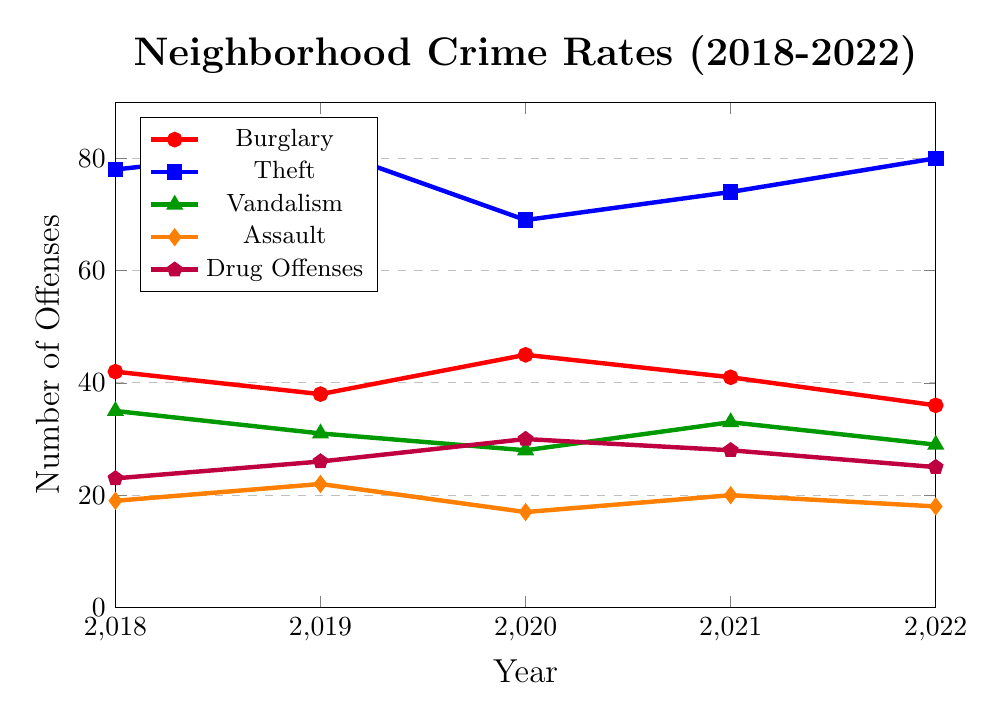What was the highest number of theft offenses in the past 5 years? Look at the blue line representing theft offenses and identify the highest point across the years. The highest point for theft offenses is in 2019 and 2022 with 82 and 80 respectively. The maximum value among these is 82 in 2019.
Answer: 82 In which year was the number of burglary offenses the lowest? Inspect the red line representing burglary offenses. The lowest point is in 2022 at 36 offenses.
Answer: 2022 How did the number of drug offenses change from 2018 to 2022? Look at the purple line representing drug offenses. In 2018, there were 23 drug offenses, and in 2022, there were 25. Subtract 23 from 25 to find the change, which is an increase of 2 offenses.
Answer: Increased by 2 Which offense had the greatest decrease from 2018 to 2022? Compare the starting and ending values for each offense from 2018 to 2022. Burglary decreased from 42 to 36 (6 offenses), Theft increased from 78 to 80 (increase, not applicable), Vandalism decreased from 35 to 29 (6 offenses), Assault decreased from 19 to 18 (1 offense), Drug Offenses increased from 23 to 25 (increase, not applicable). Burglary and Vandalism both share the greatest decrease of 6 offenses.
Answer: Burglary and Vandalism Between 2019 and 2020, which offense saw the largest decrease in offenses? Check the difference in the offense numbers between 2019 and 2020 for each type: Burglary (38 to 45, increase), Theft (82 to 69, 13 decrease), Vandalism (31 to 28, 3 decrease), Assault (22 to 17, 5 decrease), and Drug Offenses (26 to 30, increase). The largest decrease is 13 for Theft.
Answer: Theft What is the average number of assault offenses over the 5 years? Sum the number of assault offenses over 5 years and divide by 5. (19 + 22 + 17 + 20 + 18) = 96, so the average is 96/5 = 19.2
Answer: 19.2 Which year had the most even distribution of offenses among the different types? For each year, check the spread between the highest and lowest values. 2018: range is 78-19 = 59, 2019: range is 82-22 = 60, 2020: range is 69-17 = 52, 2021: range is 74-20 = 54, 2022: range is 80-18 = 62. The smallest range is in 2020 with a range of 52, indicating the most even distribution.
Answer: 2020 Which type of offense showed the most fluctuation over the 5 years? Calculate the range (max - min) for each offense over the 5 years: Burglary (45-36 = 9), Theft (82-69 = 13), Vandalism (35-28 = 7), Assault (22-17 = 5), Drug Offenses (30-23 = 7). Theft shows the greatest fluctuation with a range of 13 offenses.
Answer: Theft From 2020 to 2021, which offense showed an increase in the number of offenses? Compare the values from 2020 to 2021 for each offense: Burglary (45 to 41, decrease), Theft (69 to 74, increase), Vandalism (28 to 33, increase), Assault (17 to 20, increase), Drug Offenses (30 to 28, decrease). The offenses showing an increase are Theft, Vandalism, and Assault.
Answer: Theft, Vandalism, and Assault 